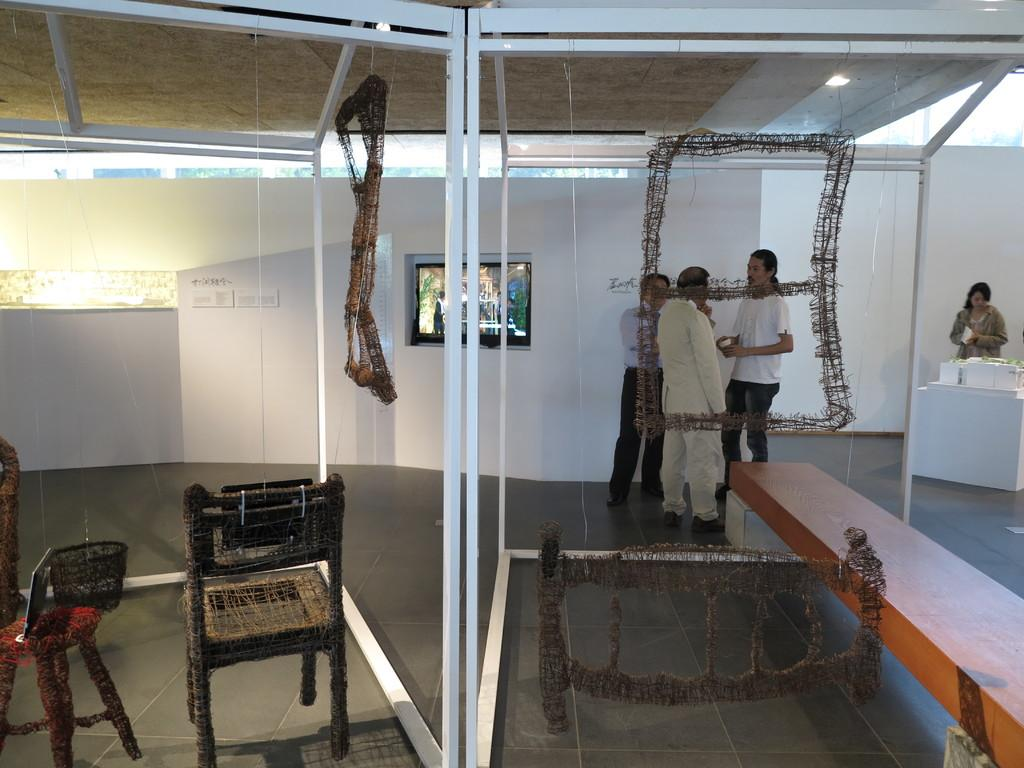How many people are present in the image? There are four persons standing in the image. What electronic device can be seen in the image? There is a television in the image. What type of furniture is present in the image? There is a stool and a chair in the image. Can you describe any other objects in the image? There are some objects in the image, but their specific nature is not mentioned in the provided facts. What type of pies are being served to the friend in the image? There is no mention of pies or a friend in the image, so this question cannot be answered. Can you tell me where the toothbrush is located in the image? There is no toothbrush present in the image. 